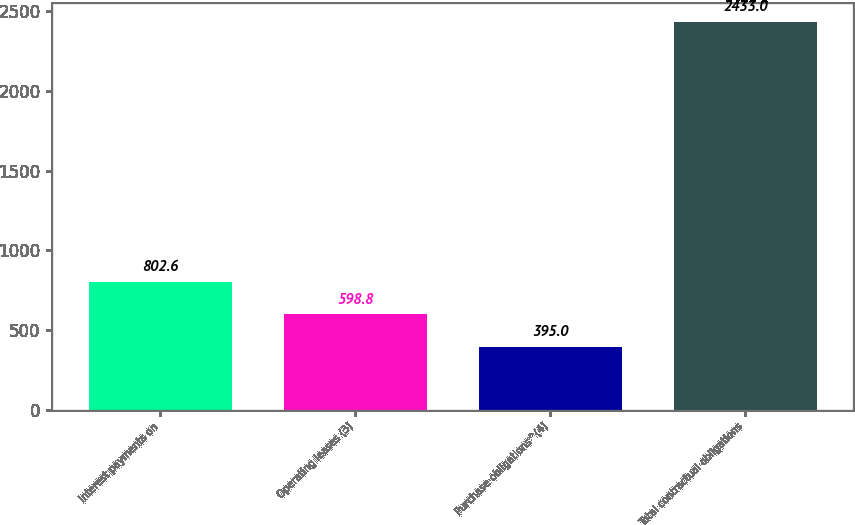Convert chart. <chart><loc_0><loc_0><loc_500><loc_500><bar_chart><fcel>Interest payments on<fcel>Operating leases (3)<fcel>Purchase obligations^(4)<fcel>Total contractual obligations<nl><fcel>802.6<fcel>598.8<fcel>395<fcel>2433<nl></chart> 